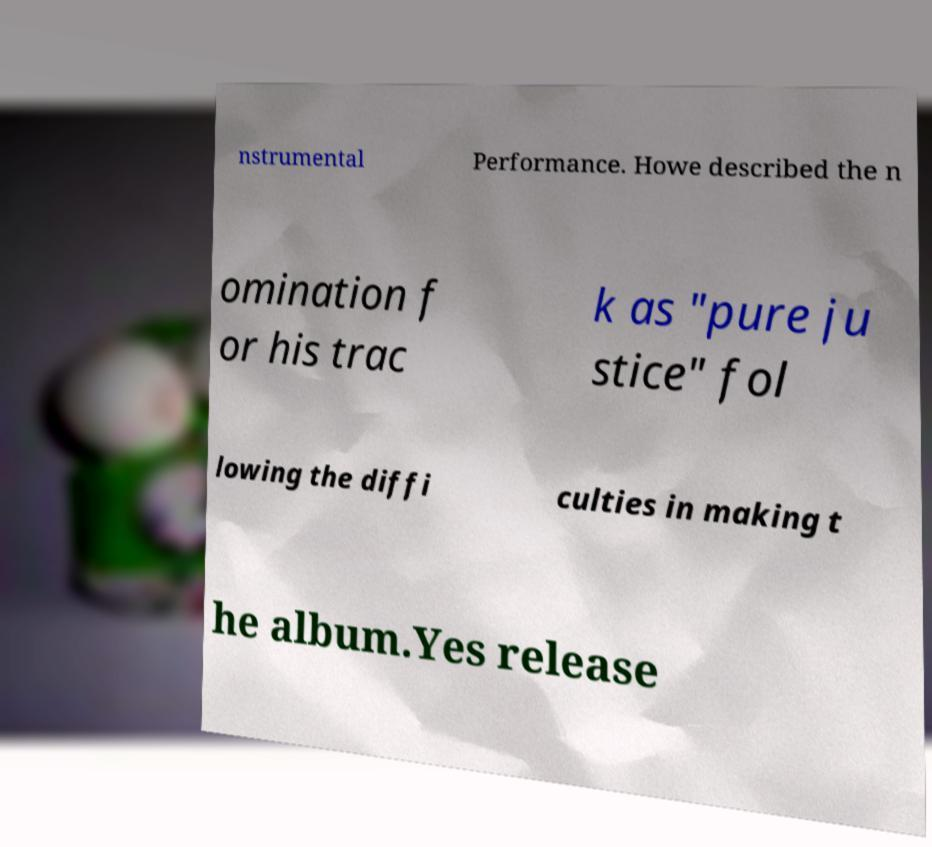What messages or text are displayed in this image? I need them in a readable, typed format. nstrumental Performance. Howe described the n omination f or his trac k as "pure ju stice" fol lowing the diffi culties in making t he album.Yes release 